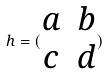<formula> <loc_0><loc_0><loc_500><loc_500>h = ( \begin{matrix} a & b \\ c & d \end{matrix} )</formula> 